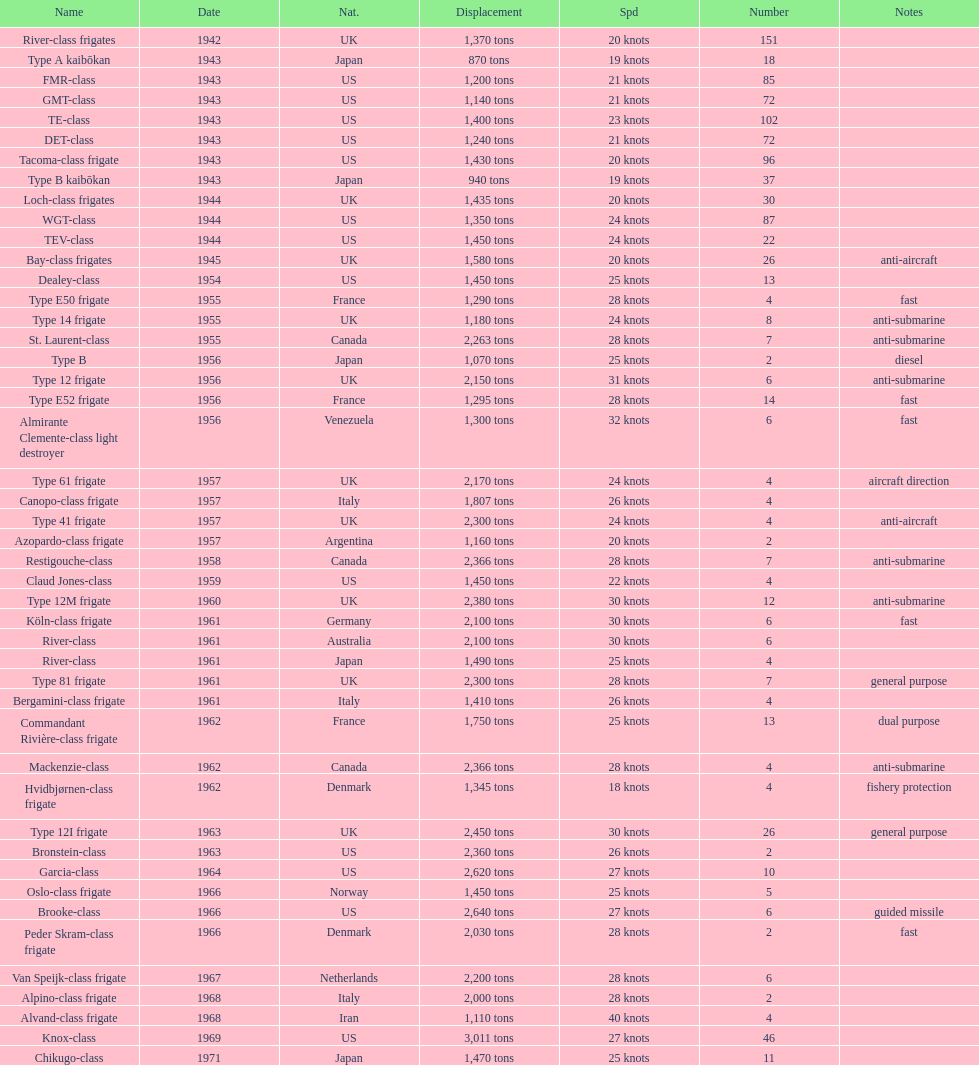What is the top speed? 40 knots. Give me the full table as a dictionary. {'header': ['Name', 'Date', 'Nat.', 'Displacement', 'Spd', 'Number', 'Notes'], 'rows': [['River-class frigates', '1942', 'UK', '1,370 tons', '20 knots', '151', ''], ['Type A kaibōkan', '1943', 'Japan', '870 tons', '19 knots', '18', ''], ['FMR-class', '1943', 'US', '1,200 tons', '21 knots', '85', ''], ['GMT-class', '1943', 'US', '1,140 tons', '21 knots', '72', ''], ['TE-class', '1943', 'US', '1,400 tons', '23 knots', '102', ''], ['DET-class', '1943', 'US', '1,240 tons', '21 knots', '72', ''], ['Tacoma-class frigate', '1943', 'US', '1,430 tons', '20 knots', '96', ''], ['Type B kaibōkan', '1943', 'Japan', '940 tons', '19 knots', '37', ''], ['Loch-class frigates', '1944', 'UK', '1,435 tons', '20 knots', '30', ''], ['WGT-class', '1944', 'US', '1,350 tons', '24 knots', '87', ''], ['TEV-class', '1944', 'US', '1,450 tons', '24 knots', '22', ''], ['Bay-class frigates', '1945', 'UK', '1,580 tons', '20 knots', '26', 'anti-aircraft'], ['Dealey-class', '1954', 'US', '1,450 tons', '25 knots', '13', ''], ['Type E50 frigate', '1955', 'France', '1,290 tons', '28 knots', '4', 'fast'], ['Type 14 frigate', '1955', 'UK', '1,180 tons', '24 knots', '8', 'anti-submarine'], ['St. Laurent-class', '1955', 'Canada', '2,263 tons', '28 knots', '7', 'anti-submarine'], ['Type B', '1956', 'Japan', '1,070 tons', '25 knots', '2', 'diesel'], ['Type 12 frigate', '1956', 'UK', '2,150 tons', '31 knots', '6', 'anti-submarine'], ['Type E52 frigate', '1956', 'France', '1,295 tons', '28 knots', '14', 'fast'], ['Almirante Clemente-class light destroyer', '1956', 'Venezuela', '1,300 tons', '32 knots', '6', 'fast'], ['Type 61 frigate', '1957', 'UK', '2,170 tons', '24 knots', '4', 'aircraft direction'], ['Canopo-class frigate', '1957', 'Italy', '1,807 tons', '26 knots', '4', ''], ['Type 41 frigate', '1957', 'UK', '2,300 tons', '24 knots', '4', 'anti-aircraft'], ['Azopardo-class frigate', '1957', 'Argentina', '1,160 tons', '20 knots', '2', ''], ['Restigouche-class', '1958', 'Canada', '2,366 tons', '28 knots', '7', 'anti-submarine'], ['Claud Jones-class', '1959', 'US', '1,450 tons', '22 knots', '4', ''], ['Type 12M frigate', '1960', 'UK', '2,380 tons', '30 knots', '12', 'anti-submarine'], ['Köln-class frigate', '1961', 'Germany', '2,100 tons', '30 knots', '6', 'fast'], ['River-class', '1961', 'Australia', '2,100 tons', '30 knots', '6', ''], ['River-class', '1961', 'Japan', '1,490 tons', '25 knots', '4', ''], ['Type 81 frigate', '1961', 'UK', '2,300 tons', '28 knots', '7', 'general purpose'], ['Bergamini-class frigate', '1961', 'Italy', '1,410 tons', '26 knots', '4', ''], ['Commandant Rivière-class frigate', '1962', 'France', '1,750 tons', '25 knots', '13', 'dual purpose'], ['Mackenzie-class', '1962', 'Canada', '2,366 tons', '28 knots', '4', 'anti-submarine'], ['Hvidbjørnen-class frigate', '1962', 'Denmark', '1,345 tons', '18 knots', '4', 'fishery protection'], ['Type 12I frigate', '1963', 'UK', '2,450 tons', '30 knots', '26', 'general purpose'], ['Bronstein-class', '1963', 'US', '2,360 tons', '26 knots', '2', ''], ['Garcia-class', '1964', 'US', '2,620 tons', '27 knots', '10', ''], ['Oslo-class frigate', '1966', 'Norway', '1,450 tons', '25 knots', '5', ''], ['Brooke-class', '1966', 'US', '2,640 tons', '27 knots', '6', 'guided missile'], ['Peder Skram-class frigate', '1966', 'Denmark', '2,030 tons', '28 knots', '2', 'fast'], ['Van Speijk-class frigate', '1967', 'Netherlands', '2,200 tons', '28 knots', '6', ''], ['Alpino-class frigate', '1968', 'Italy', '2,000 tons', '28 knots', '2', ''], ['Alvand-class frigate', '1968', 'Iran', '1,110 tons', '40 knots', '4', ''], ['Knox-class', '1969', 'US', '3,011 tons', '27 knots', '46', ''], ['Chikugo-class', '1971', 'Japan', '1,470 tons', '25 knots', '11', '']]} 